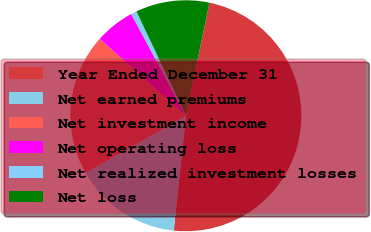Convert chart to OTSL. <chart><loc_0><loc_0><loc_500><loc_500><pie_chart><fcel>Year Ended December 31<fcel>Net earned premiums<fcel>Net investment income<fcel>Net operating loss<fcel>Net realized investment losses<fcel>Net loss<nl><fcel>48.41%<fcel>15.08%<fcel>19.84%<fcel>5.56%<fcel>0.8%<fcel>10.32%<nl></chart> 